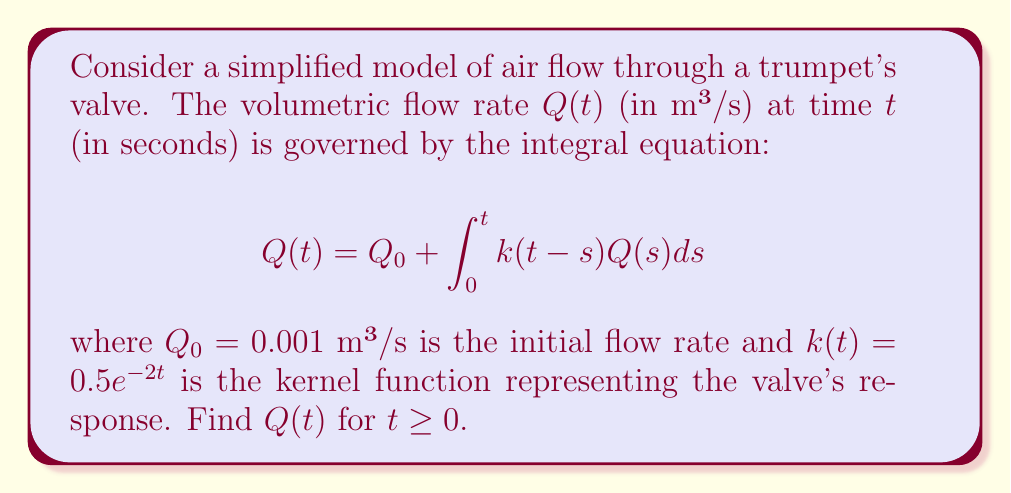Can you solve this math problem? To solve this integral equation, we'll use the Laplace transform method:

1) Take the Laplace transform of both sides:
   $$\mathcal{L}\{Q(t)\} = \mathcal{L}\{Q_0\} + \mathcal{L}\{\int_0^t k(t-s)Q(s)ds\}$$

2) Using the property of Laplace transform for constants and convolution:
   $$\hat{Q}(s) = \frac{Q_0}{s} + \hat{k}(s)\hat{Q}(s)$$

3) Calculate $\hat{k}(s)$:
   $$\hat{k}(s) = \mathcal{L}\{0.5e^{-2t}\} = \frac{0.5}{s+2}$$

4) Substitute and solve for $\hat{Q}(s)$:
   $$\hat{Q}(s) = \frac{0.001}{s} + \frac{0.5}{s+2}\hat{Q}(s)$$
   $$\hat{Q}(s)(1 - \frac{0.5}{s+2}) = \frac{0.001}{s}$$
   $$\hat{Q}(s) = \frac{0.001(s+2)}{s(s+2-0.5)} = \frac{0.001(s+2)}{s(s+1.5)}$$

5) Partial fraction decomposition:
   $$\hat{Q}(s) = \frac{A}{s} + \frac{B}{s+1.5}$$
   $$A = 0.001, B = \frac{0.001}{1.5} = \frac{2}{3000}$$

6) Take the inverse Laplace transform:
   $$Q(t) = 0.001 + \frac{2}{3000}e^{-1.5t}$$

This is the solution for $Q(t)$ when $t \geq 0$.
Answer: $Q(t) = 0.001 + \frac{2}{3000}e^{-1.5t}$ for $t \geq 0$ 